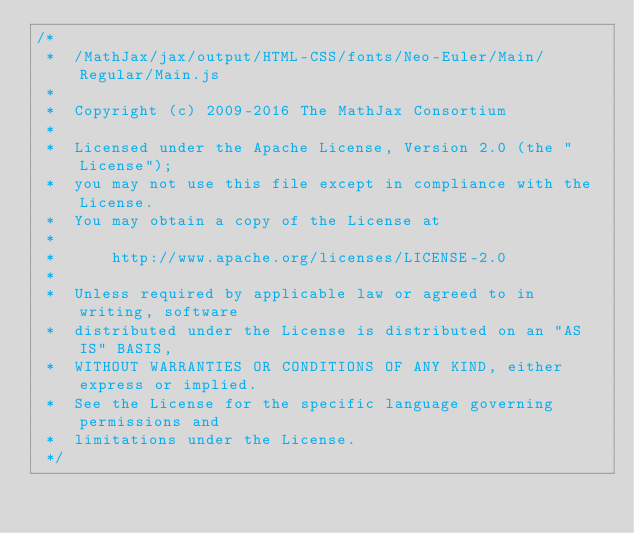Convert code to text. <code><loc_0><loc_0><loc_500><loc_500><_JavaScript_>/*
 *  /MathJax/jax/output/HTML-CSS/fonts/Neo-Euler/Main/Regular/Main.js
 *
 *  Copyright (c) 2009-2016 The MathJax Consortium
 *
 *  Licensed under the Apache License, Version 2.0 (the "License");
 *  you may not use this file except in compliance with the License.
 *  You may obtain a copy of the License at
 *
 *      http://www.apache.org/licenses/LICENSE-2.0
 *
 *  Unless required by applicable law or agreed to in writing, software
 *  distributed under the License is distributed on an "AS IS" BASIS,
 *  WITHOUT WARRANTIES OR CONDITIONS OF ANY KIND, either express or implied.
 *  See the License for the specific language governing permissions and
 *  limitations under the License.
 */
</code> 